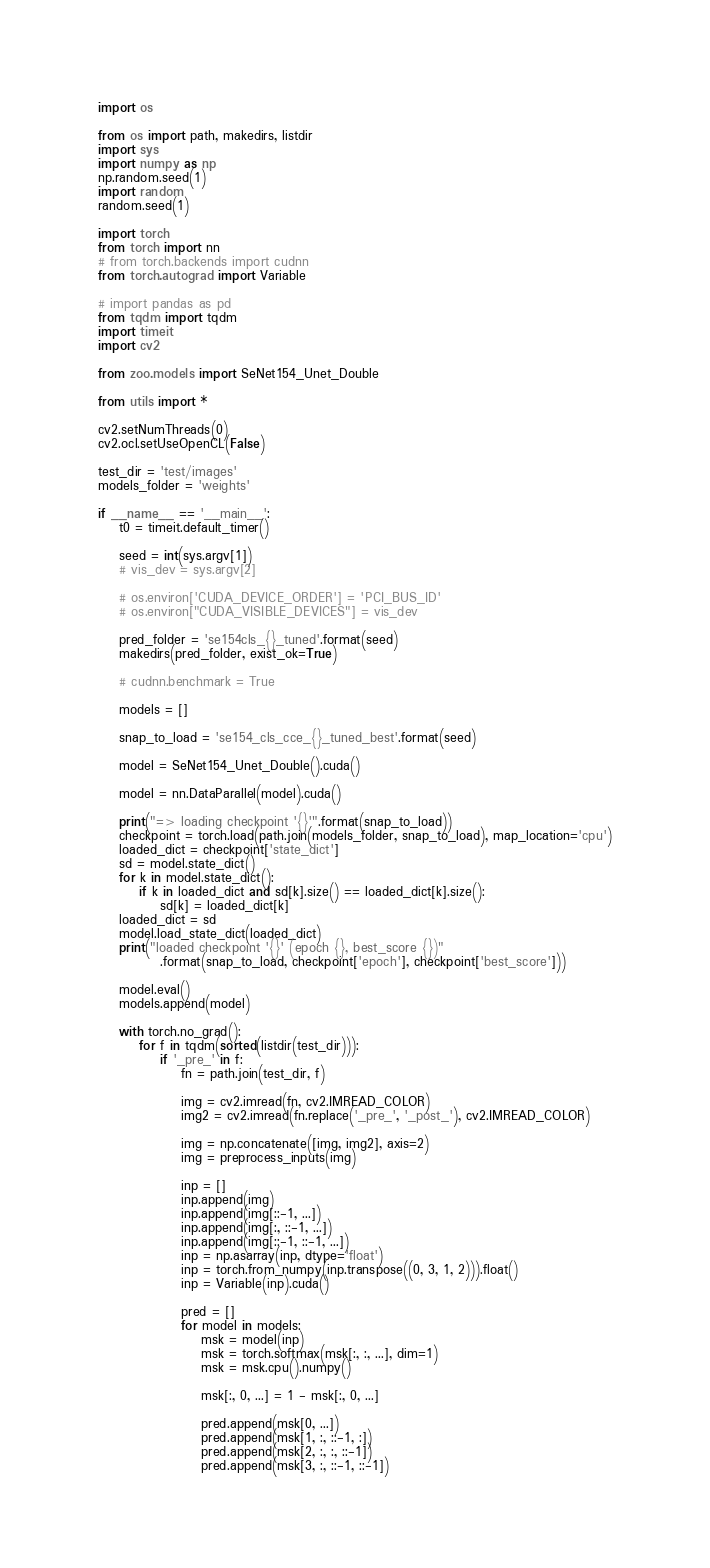<code> <loc_0><loc_0><loc_500><loc_500><_Python_>import os

from os import path, makedirs, listdir
import sys
import numpy as np
np.random.seed(1)
import random
random.seed(1)

import torch
from torch import nn
# from torch.backends import cudnn
from torch.autograd import Variable

# import pandas as pd
from tqdm import tqdm
import timeit
import cv2

from zoo.models import SeNet154_Unet_Double

from utils import *

cv2.setNumThreads(0)
cv2.ocl.setUseOpenCL(False)

test_dir = 'test/images'
models_folder = 'weights'

if __name__ == '__main__':
    t0 = timeit.default_timer()

    seed = int(sys.argv[1])
    # vis_dev = sys.argv[2]

    # os.environ['CUDA_DEVICE_ORDER'] = 'PCI_BUS_ID'
    # os.environ["CUDA_VISIBLE_DEVICES"] = vis_dev

    pred_folder = 'se154cls_{}_tuned'.format(seed)
    makedirs(pred_folder, exist_ok=True)

    # cudnn.benchmark = True

    models = []

    snap_to_load = 'se154_cls_cce_{}_tuned_best'.format(seed)

    model = SeNet154_Unet_Double().cuda()

    model = nn.DataParallel(model).cuda()
    
    print("=> loading checkpoint '{}'".format(snap_to_load))
    checkpoint = torch.load(path.join(models_folder, snap_to_load), map_location='cpu')
    loaded_dict = checkpoint['state_dict']
    sd = model.state_dict()
    for k in model.state_dict():
        if k in loaded_dict and sd[k].size() == loaded_dict[k].size():
            sd[k] = loaded_dict[k]
    loaded_dict = sd
    model.load_state_dict(loaded_dict)
    print("loaded checkpoint '{}' (epoch {}, best_score {})"
            .format(snap_to_load, checkpoint['epoch'], checkpoint['best_score']))

    model.eval()
    models.append(model)

    with torch.no_grad():
        for f in tqdm(sorted(listdir(test_dir))):
            if '_pre_' in f:
                fn = path.join(test_dir, f)

                img = cv2.imread(fn, cv2.IMREAD_COLOR)
                img2 = cv2.imread(fn.replace('_pre_', '_post_'), cv2.IMREAD_COLOR)

                img = np.concatenate([img, img2], axis=2)
                img = preprocess_inputs(img)

                inp = []
                inp.append(img)
                inp.append(img[::-1, ...])
                inp.append(img[:, ::-1, ...])
                inp.append(img[::-1, ::-1, ...])
                inp = np.asarray(inp, dtype='float')
                inp = torch.from_numpy(inp.transpose((0, 3, 1, 2))).float()
                inp = Variable(inp).cuda()

                pred = []
                for model in models:               
                    msk = model(inp)
                    msk = torch.softmax(msk[:, :, ...], dim=1)
                    msk = msk.cpu().numpy()
                    
                    msk[:, 0, ...] = 1 - msk[:, 0, ...]
                    
                    pred.append(msk[0, ...])
                    pred.append(msk[1, :, ::-1, :])
                    pred.append(msk[2, :, :, ::-1])
                    pred.append(msk[3, :, ::-1, ::-1])
</code> 